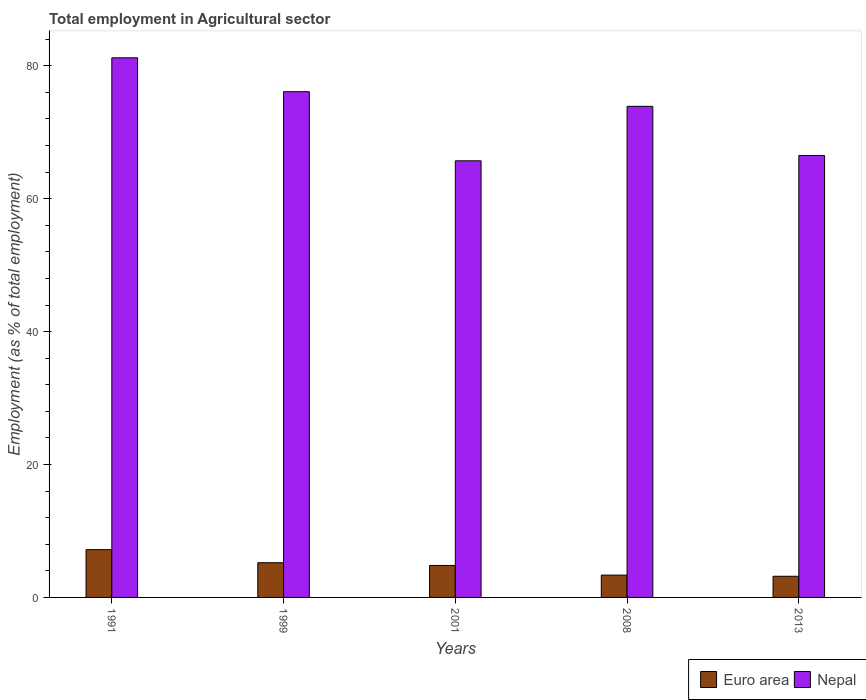How many bars are there on the 1st tick from the left?
Your response must be concise. 2. How many bars are there on the 3rd tick from the right?
Offer a very short reply. 2. In how many cases, is the number of bars for a given year not equal to the number of legend labels?
Your answer should be very brief. 0. What is the employment in agricultural sector in Euro area in 1991?
Your response must be concise. 7.19. Across all years, what is the maximum employment in agricultural sector in Euro area?
Offer a very short reply. 7.19. Across all years, what is the minimum employment in agricultural sector in Nepal?
Your answer should be compact. 65.7. What is the total employment in agricultural sector in Euro area in the graph?
Offer a very short reply. 23.77. What is the difference between the employment in agricultural sector in Euro area in 1999 and that in 2013?
Keep it short and to the point. 2.04. What is the difference between the employment in agricultural sector in Nepal in 2008 and the employment in agricultural sector in Euro area in 1999?
Provide a succinct answer. 68.68. What is the average employment in agricultural sector in Nepal per year?
Give a very brief answer. 72.68. In the year 1991, what is the difference between the employment in agricultural sector in Nepal and employment in agricultural sector in Euro area?
Your answer should be compact. 74.01. In how many years, is the employment in agricultural sector in Euro area greater than 20 %?
Keep it short and to the point. 0. What is the ratio of the employment in agricultural sector in Nepal in 1991 to that in 2008?
Make the answer very short. 1.1. Is the difference between the employment in agricultural sector in Nepal in 2008 and 2013 greater than the difference between the employment in agricultural sector in Euro area in 2008 and 2013?
Ensure brevity in your answer.  Yes. What is the difference between the highest and the second highest employment in agricultural sector in Nepal?
Make the answer very short. 5.1. What is the difference between the highest and the lowest employment in agricultural sector in Euro area?
Give a very brief answer. 4.01. In how many years, is the employment in agricultural sector in Nepal greater than the average employment in agricultural sector in Nepal taken over all years?
Offer a terse response. 3. Is the sum of the employment in agricultural sector in Euro area in 1999 and 2013 greater than the maximum employment in agricultural sector in Nepal across all years?
Give a very brief answer. No. What does the 2nd bar from the left in 2008 represents?
Provide a succinct answer. Nepal. What does the 2nd bar from the right in 2008 represents?
Ensure brevity in your answer.  Euro area. What is the difference between two consecutive major ticks on the Y-axis?
Ensure brevity in your answer.  20. Does the graph contain any zero values?
Ensure brevity in your answer.  No. What is the title of the graph?
Your answer should be very brief. Total employment in Agricultural sector. What is the label or title of the X-axis?
Your answer should be very brief. Years. What is the label or title of the Y-axis?
Your answer should be compact. Employment (as % of total employment). What is the Employment (as % of total employment) of Euro area in 1991?
Make the answer very short. 7.19. What is the Employment (as % of total employment) of Nepal in 1991?
Keep it short and to the point. 81.2. What is the Employment (as % of total employment) of Euro area in 1999?
Your response must be concise. 5.22. What is the Employment (as % of total employment) in Nepal in 1999?
Ensure brevity in your answer.  76.1. What is the Employment (as % of total employment) of Euro area in 2001?
Your response must be concise. 4.81. What is the Employment (as % of total employment) in Nepal in 2001?
Your response must be concise. 65.7. What is the Employment (as % of total employment) in Euro area in 2008?
Ensure brevity in your answer.  3.36. What is the Employment (as % of total employment) in Nepal in 2008?
Ensure brevity in your answer.  73.9. What is the Employment (as % of total employment) of Euro area in 2013?
Your answer should be compact. 3.18. What is the Employment (as % of total employment) in Nepal in 2013?
Your answer should be very brief. 66.5. Across all years, what is the maximum Employment (as % of total employment) in Euro area?
Offer a very short reply. 7.19. Across all years, what is the maximum Employment (as % of total employment) in Nepal?
Give a very brief answer. 81.2. Across all years, what is the minimum Employment (as % of total employment) of Euro area?
Make the answer very short. 3.18. Across all years, what is the minimum Employment (as % of total employment) of Nepal?
Provide a succinct answer. 65.7. What is the total Employment (as % of total employment) of Euro area in the graph?
Give a very brief answer. 23.77. What is the total Employment (as % of total employment) of Nepal in the graph?
Offer a very short reply. 363.4. What is the difference between the Employment (as % of total employment) in Euro area in 1991 and that in 1999?
Your answer should be compact. 1.97. What is the difference between the Employment (as % of total employment) of Euro area in 1991 and that in 2001?
Provide a short and direct response. 2.38. What is the difference between the Employment (as % of total employment) of Euro area in 1991 and that in 2008?
Your answer should be very brief. 3.83. What is the difference between the Employment (as % of total employment) in Euro area in 1991 and that in 2013?
Offer a very short reply. 4.01. What is the difference between the Employment (as % of total employment) of Nepal in 1991 and that in 2013?
Make the answer very short. 14.7. What is the difference between the Employment (as % of total employment) in Euro area in 1999 and that in 2001?
Offer a very short reply. 0.41. What is the difference between the Employment (as % of total employment) in Euro area in 1999 and that in 2008?
Keep it short and to the point. 1.86. What is the difference between the Employment (as % of total employment) in Nepal in 1999 and that in 2008?
Provide a short and direct response. 2.2. What is the difference between the Employment (as % of total employment) of Euro area in 1999 and that in 2013?
Your response must be concise. 2.04. What is the difference between the Employment (as % of total employment) in Euro area in 2001 and that in 2008?
Ensure brevity in your answer.  1.45. What is the difference between the Employment (as % of total employment) in Nepal in 2001 and that in 2008?
Provide a short and direct response. -8.2. What is the difference between the Employment (as % of total employment) of Euro area in 2001 and that in 2013?
Make the answer very short. 1.63. What is the difference between the Employment (as % of total employment) in Nepal in 2001 and that in 2013?
Your answer should be compact. -0.8. What is the difference between the Employment (as % of total employment) in Euro area in 2008 and that in 2013?
Give a very brief answer. 0.18. What is the difference between the Employment (as % of total employment) in Euro area in 1991 and the Employment (as % of total employment) in Nepal in 1999?
Your response must be concise. -68.91. What is the difference between the Employment (as % of total employment) in Euro area in 1991 and the Employment (as % of total employment) in Nepal in 2001?
Provide a short and direct response. -58.51. What is the difference between the Employment (as % of total employment) of Euro area in 1991 and the Employment (as % of total employment) of Nepal in 2008?
Offer a terse response. -66.71. What is the difference between the Employment (as % of total employment) in Euro area in 1991 and the Employment (as % of total employment) in Nepal in 2013?
Make the answer very short. -59.31. What is the difference between the Employment (as % of total employment) in Euro area in 1999 and the Employment (as % of total employment) in Nepal in 2001?
Your answer should be compact. -60.48. What is the difference between the Employment (as % of total employment) in Euro area in 1999 and the Employment (as % of total employment) in Nepal in 2008?
Offer a terse response. -68.68. What is the difference between the Employment (as % of total employment) in Euro area in 1999 and the Employment (as % of total employment) in Nepal in 2013?
Ensure brevity in your answer.  -61.28. What is the difference between the Employment (as % of total employment) of Euro area in 2001 and the Employment (as % of total employment) of Nepal in 2008?
Make the answer very short. -69.09. What is the difference between the Employment (as % of total employment) in Euro area in 2001 and the Employment (as % of total employment) in Nepal in 2013?
Keep it short and to the point. -61.69. What is the difference between the Employment (as % of total employment) of Euro area in 2008 and the Employment (as % of total employment) of Nepal in 2013?
Your answer should be very brief. -63.14. What is the average Employment (as % of total employment) in Euro area per year?
Your answer should be very brief. 4.75. What is the average Employment (as % of total employment) in Nepal per year?
Make the answer very short. 72.68. In the year 1991, what is the difference between the Employment (as % of total employment) in Euro area and Employment (as % of total employment) in Nepal?
Give a very brief answer. -74.01. In the year 1999, what is the difference between the Employment (as % of total employment) in Euro area and Employment (as % of total employment) in Nepal?
Your answer should be compact. -70.88. In the year 2001, what is the difference between the Employment (as % of total employment) in Euro area and Employment (as % of total employment) in Nepal?
Offer a very short reply. -60.89. In the year 2008, what is the difference between the Employment (as % of total employment) in Euro area and Employment (as % of total employment) in Nepal?
Keep it short and to the point. -70.54. In the year 2013, what is the difference between the Employment (as % of total employment) of Euro area and Employment (as % of total employment) of Nepal?
Your answer should be compact. -63.32. What is the ratio of the Employment (as % of total employment) in Euro area in 1991 to that in 1999?
Keep it short and to the point. 1.38. What is the ratio of the Employment (as % of total employment) of Nepal in 1991 to that in 1999?
Offer a terse response. 1.07. What is the ratio of the Employment (as % of total employment) of Euro area in 1991 to that in 2001?
Provide a short and direct response. 1.49. What is the ratio of the Employment (as % of total employment) of Nepal in 1991 to that in 2001?
Your answer should be compact. 1.24. What is the ratio of the Employment (as % of total employment) of Euro area in 1991 to that in 2008?
Give a very brief answer. 2.14. What is the ratio of the Employment (as % of total employment) of Nepal in 1991 to that in 2008?
Ensure brevity in your answer.  1.1. What is the ratio of the Employment (as % of total employment) in Euro area in 1991 to that in 2013?
Your answer should be very brief. 2.26. What is the ratio of the Employment (as % of total employment) in Nepal in 1991 to that in 2013?
Keep it short and to the point. 1.22. What is the ratio of the Employment (as % of total employment) of Euro area in 1999 to that in 2001?
Provide a succinct answer. 1.09. What is the ratio of the Employment (as % of total employment) of Nepal in 1999 to that in 2001?
Offer a terse response. 1.16. What is the ratio of the Employment (as % of total employment) of Euro area in 1999 to that in 2008?
Keep it short and to the point. 1.55. What is the ratio of the Employment (as % of total employment) of Nepal in 1999 to that in 2008?
Provide a short and direct response. 1.03. What is the ratio of the Employment (as % of total employment) in Euro area in 1999 to that in 2013?
Keep it short and to the point. 1.64. What is the ratio of the Employment (as % of total employment) of Nepal in 1999 to that in 2013?
Ensure brevity in your answer.  1.14. What is the ratio of the Employment (as % of total employment) of Euro area in 2001 to that in 2008?
Your response must be concise. 1.43. What is the ratio of the Employment (as % of total employment) of Nepal in 2001 to that in 2008?
Offer a terse response. 0.89. What is the ratio of the Employment (as % of total employment) of Euro area in 2001 to that in 2013?
Offer a terse response. 1.51. What is the ratio of the Employment (as % of total employment) of Euro area in 2008 to that in 2013?
Your answer should be very brief. 1.06. What is the ratio of the Employment (as % of total employment) of Nepal in 2008 to that in 2013?
Offer a terse response. 1.11. What is the difference between the highest and the second highest Employment (as % of total employment) in Euro area?
Ensure brevity in your answer.  1.97. What is the difference between the highest and the lowest Employment (as % of total employment) in Euro area?
Keep it short and to the point. 4.01. What is the difference between the highest and the lowest Employment (as % of total employment) of Nepal?
Keep it short and to the point. 15.5. 